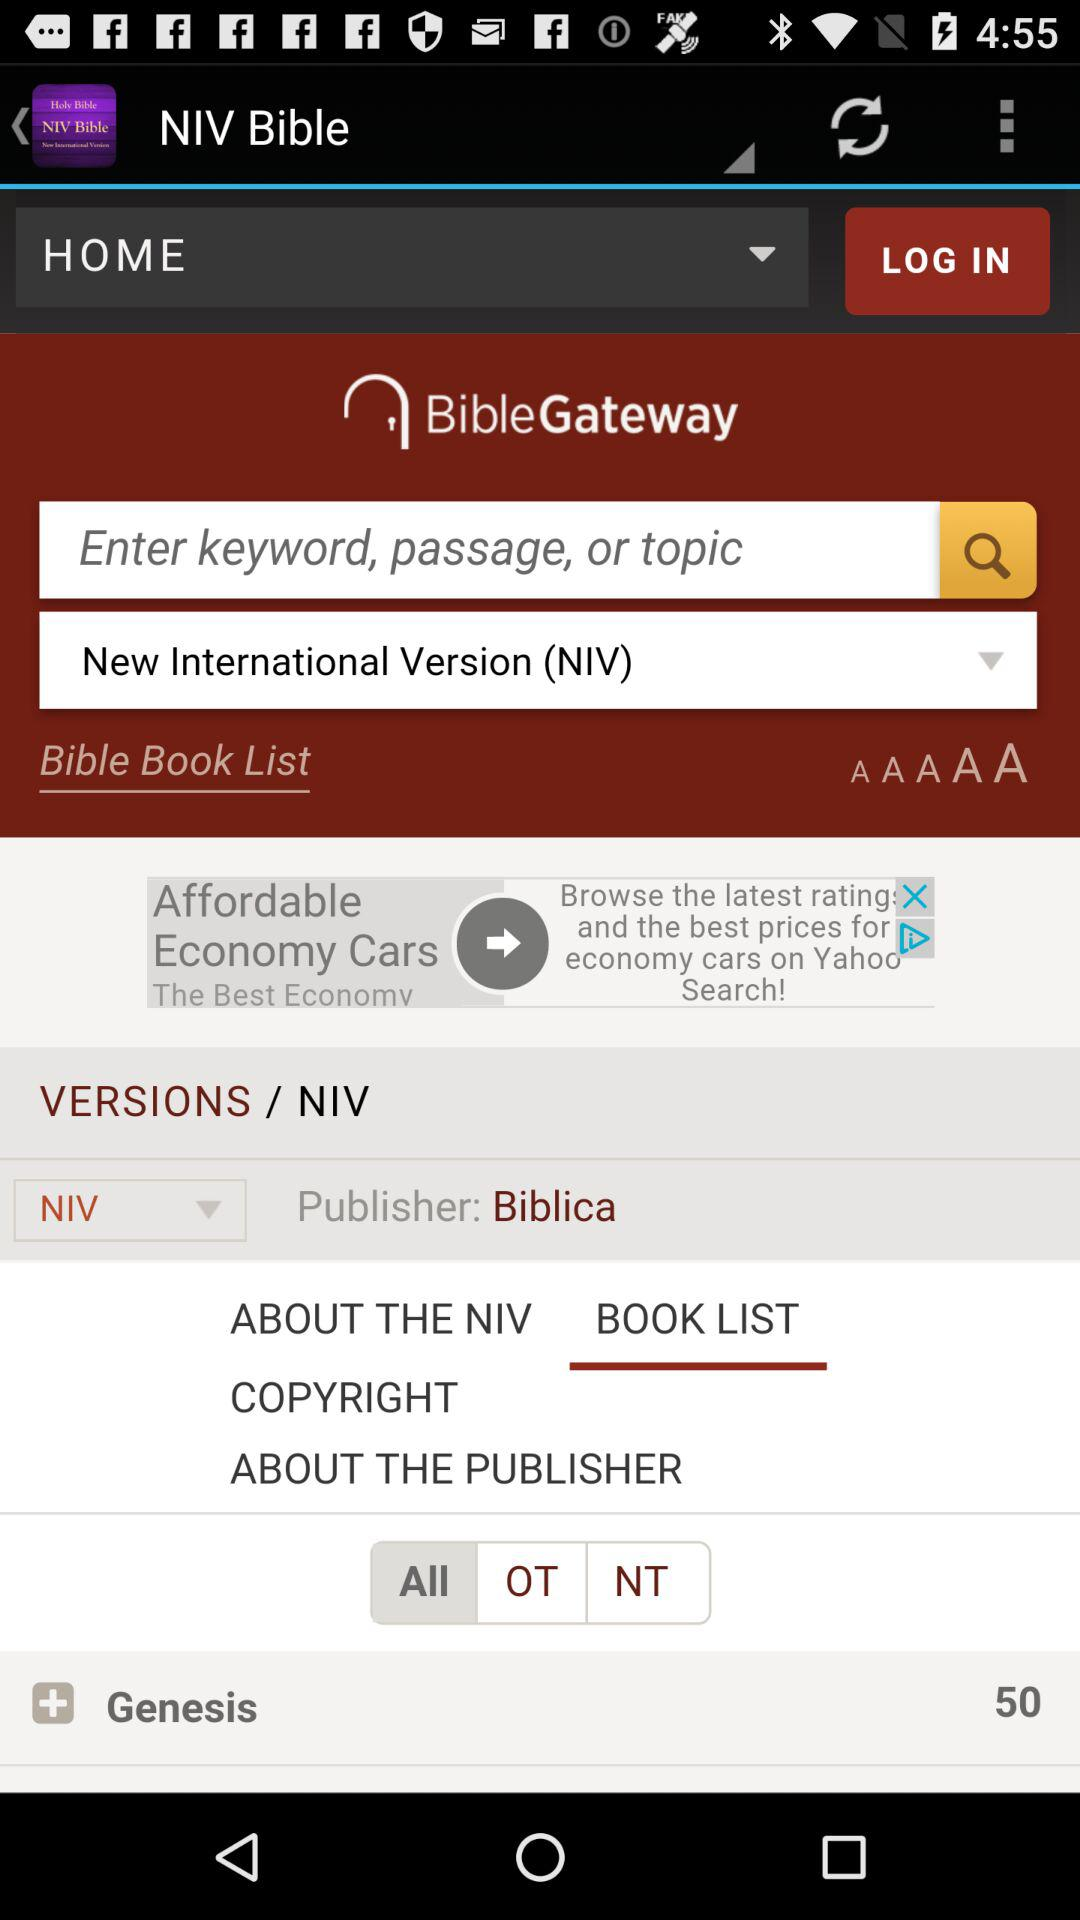Who is the publisher? The publisher is "Biblica". 